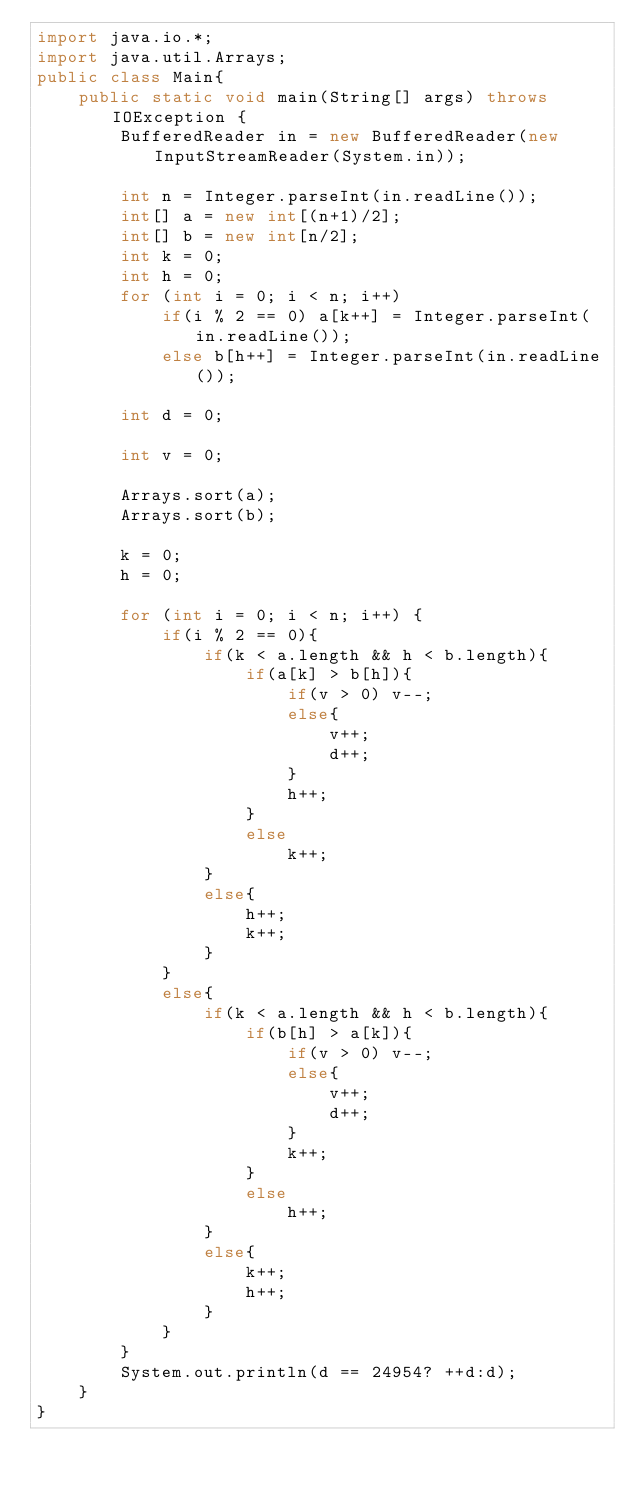<code> <loc_0><loc_0><loc_500><loc_500><_Java_>import java.io.*;
import java.util.Arrays;
public class Main{
	public static void main(String[] args) throws IOException {
		BufferedReader in = new BufferedReader(new InputStreamReader(System.in));
		
		int n = Integer.parseInt(in.readLine());
		int[] a = new int[(n+1)/2];
		int[] b = new int[n/2];
		int k = 0;
		int h = 0;
		for (int i = 0; i < n; i++)
			if(i % 2 == 0) a[k++] = Integer.parseInt(in.readLine());
			else b[h++] = Integer.parseInt(in.readLine());
		
		int d = 0;
		
		int v = 0;
		
		Arrays.sort(a);
		Arrays.sort(b);
		
		k = 0;
		h = 0;
		
		for (int i = 0; i < n; i++) {
			if(i % 2 == 0){
				if(k < a.length && h < b.length){
					if(a[k] > b[h]){
						if(v > 0) v--;
						else{
							v++;
							d++;
						}
						h++;
					}
					else
						k++;
				}
				else{
					h++;
					k++;
				}
			}
			else{
				if(k < a.length && h < b.length){
					if(b[h] > a[k]){
						if(v > 0) v--;
						else{
							v++;
							d++;
						}
						k++;
					}
					else 
						h++;
				}
				else{
					k++;
					h++;
				}
			}
		}
		System.out.println(d == 24954? ++d:d);
	}
}</code> 